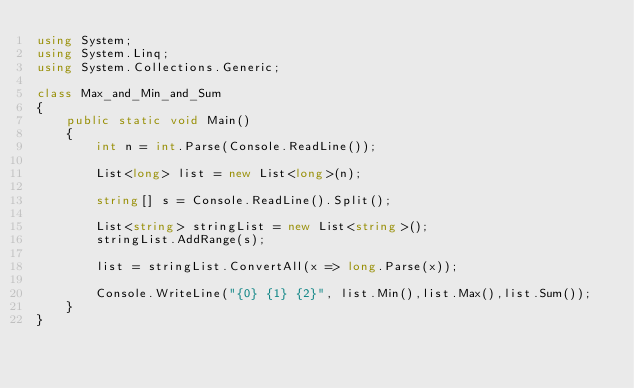Convert code to text. <code><loc_0><loc_0><loc_500><loc_500><_C#_>using System;
using System.Linq;
using System.Collections.Generic;

class Max_and_Min_and_Sum
{
    public static void Main()
    {
        int n = int.Parse(Console.ReadLine());

        List<long> list = new List<long>(n);

        string[] s = Console.ReadLine().Split();

        List<string> stringList = new List<string>();
        stringList.AddRange(s);

        list = stringList.ConvertAll(x => long.Parse(x));

        Console.WriteLine("{0} {1} {2}", list.Min(),list.Max(),list.Sum());
    }
}

</code> 